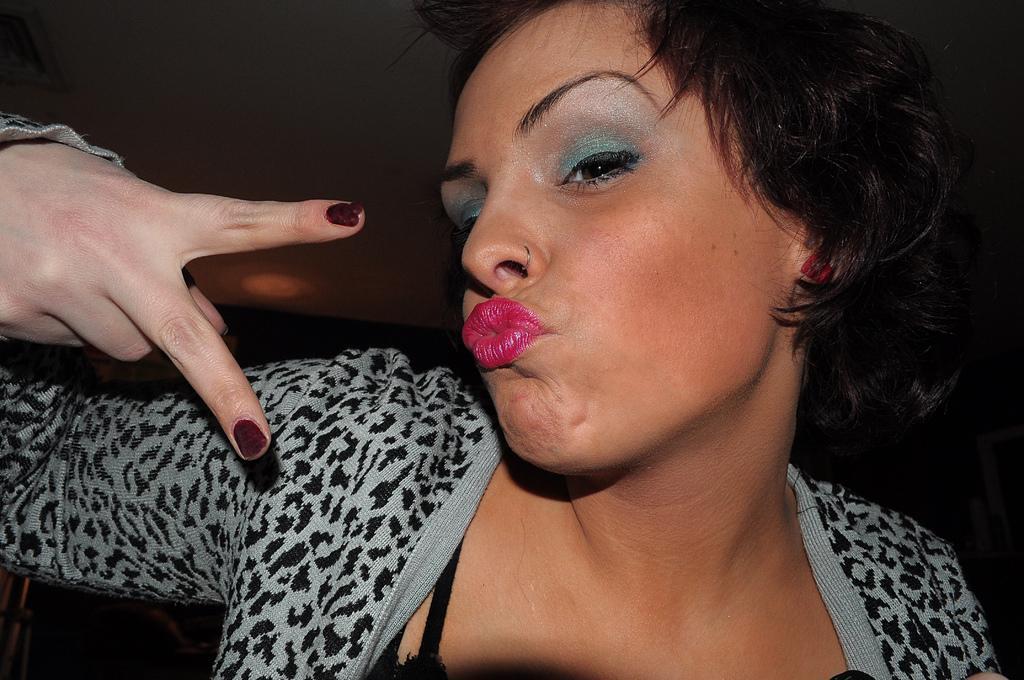In one or two sentences, can you explain what this image depicts? In this picture I can see a woman in front, who is wearing white and black color dress and I see that it is a bit dark in the background. 